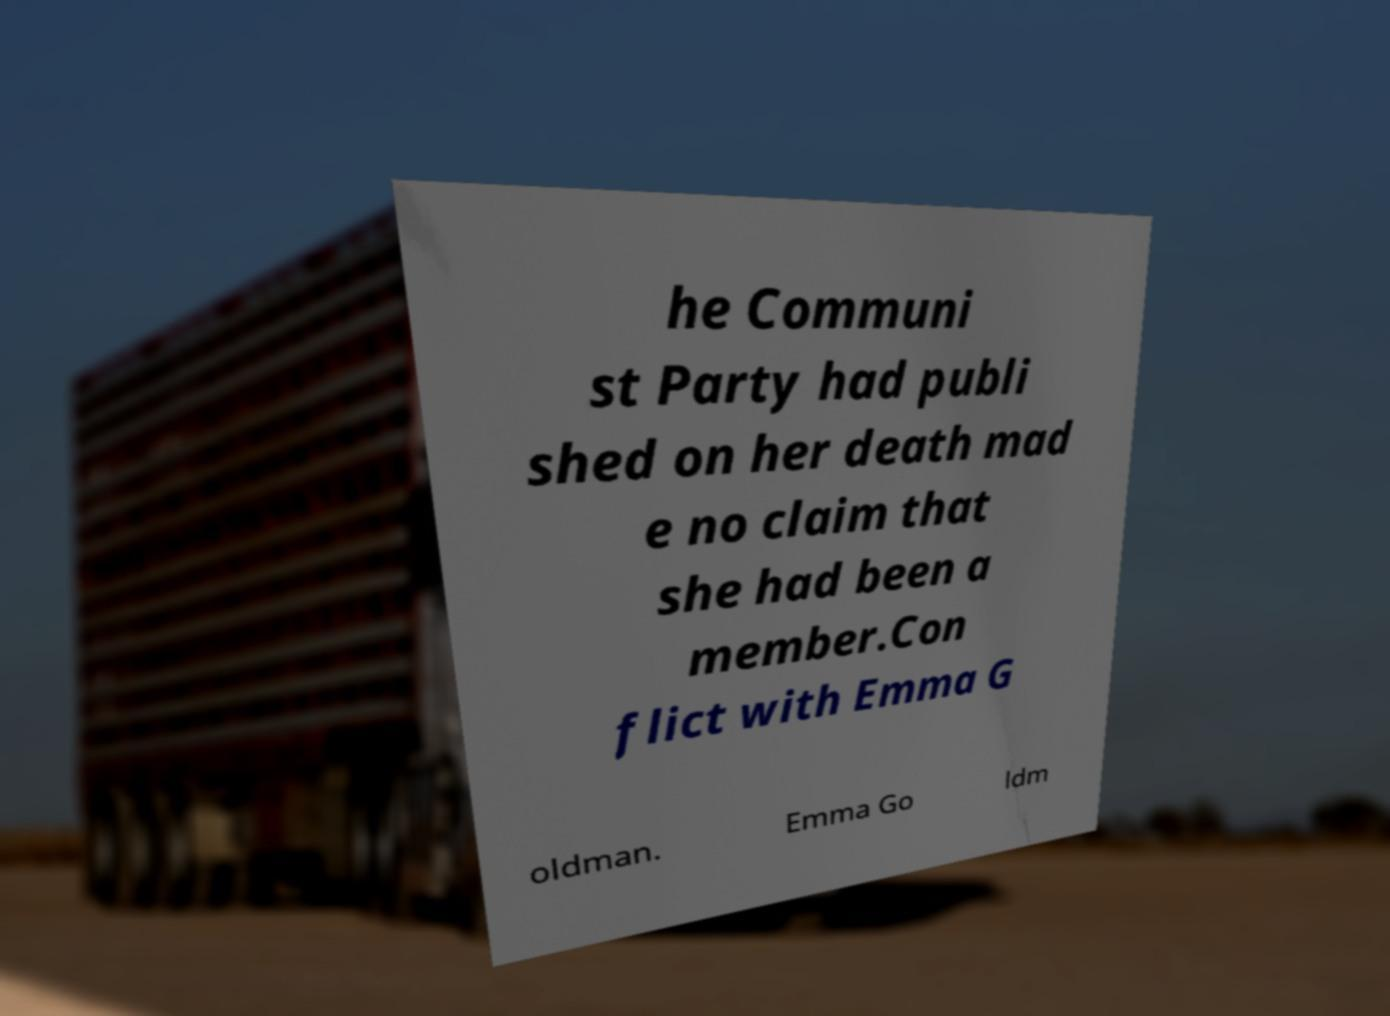Could you assist in decoding the text presented in this image and type it out clearly? he Communi st Party had publi shed on her death mad e no claim that she had been a member.Con flict with Emma G oldman. Emma Go ldm 